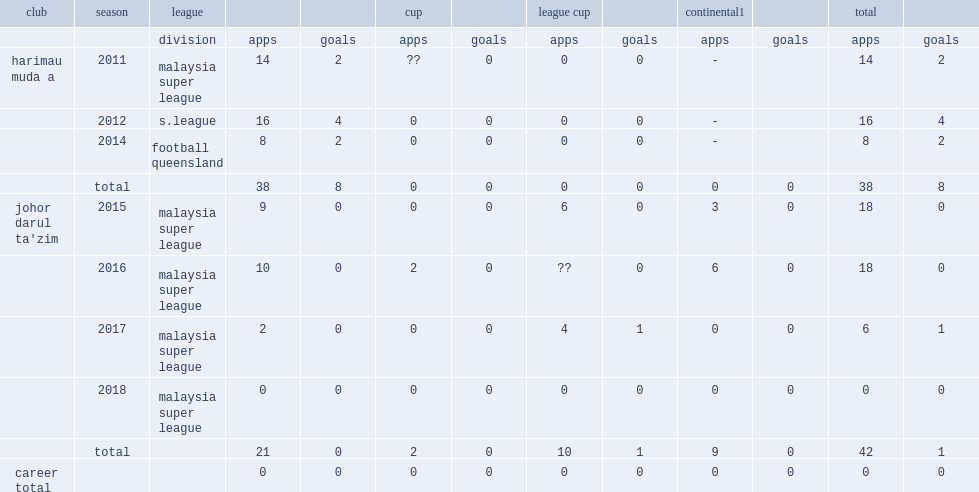In 2011, which league did robbat play in? Malaysia super league. 